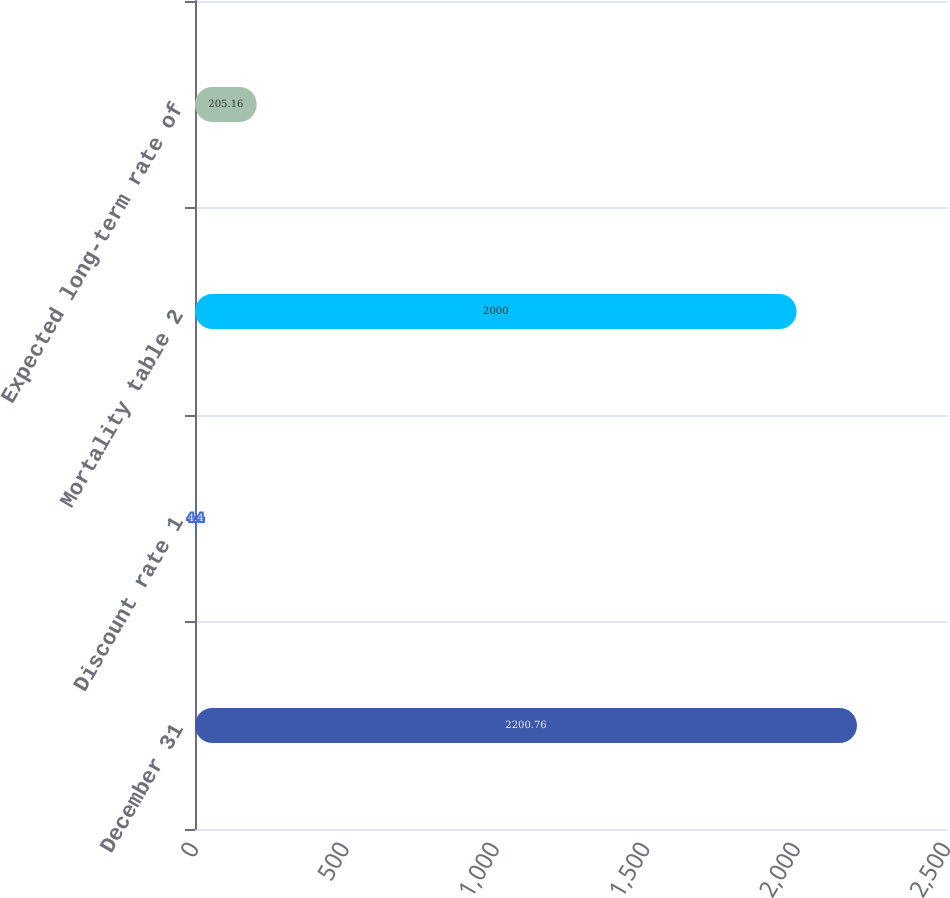Convert chart. <chart><loc_0><loc_0><loc_500><loc_500><bar_chart><fcel>December 31<fcel>Discount rate 1<fcel>Mortality table 2<fcel>Expected long-term rate of<nl><fcel>2200.76<fcel>4.4<fcel>2000<fcel>205.16<nl></chart> 